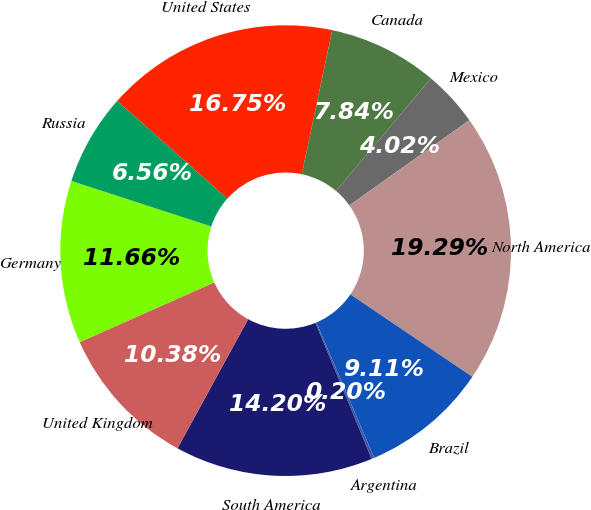Convert chart to OTSL. <chart><loc_0><loc_0><loc_500><loc_500><pie_chart><fcel>United States<fcel>Canada<fcel>Mexico<fcel>North America<fcel>Brazil<fcel>Argentina<fcel>South America<fcel>United Kingdom<fcel>Germany<fcel>Russia<nl><fcel>16.75%<fcel>7.84%<fcel>4.02%<fcel>19.29%<fcel>9.11%<fcel>0.2%<fcel>14.2%<fcel>10.38%<fcel>11.66%<fcel>6.56%<nl></chart> 